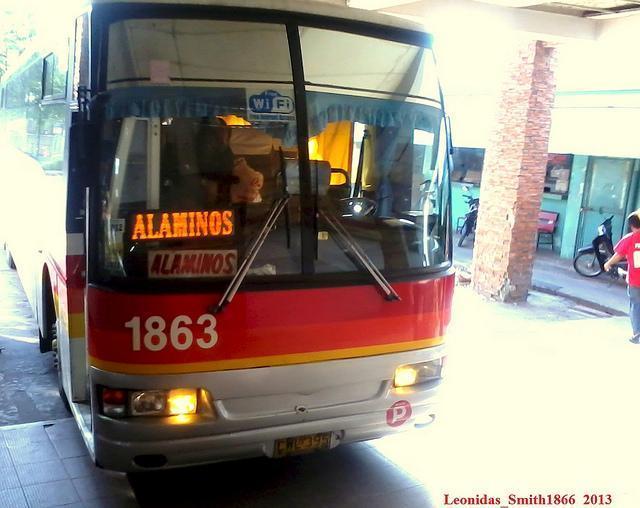How many sinks are to the right of the shower?
Give a very brief answer. 0. 